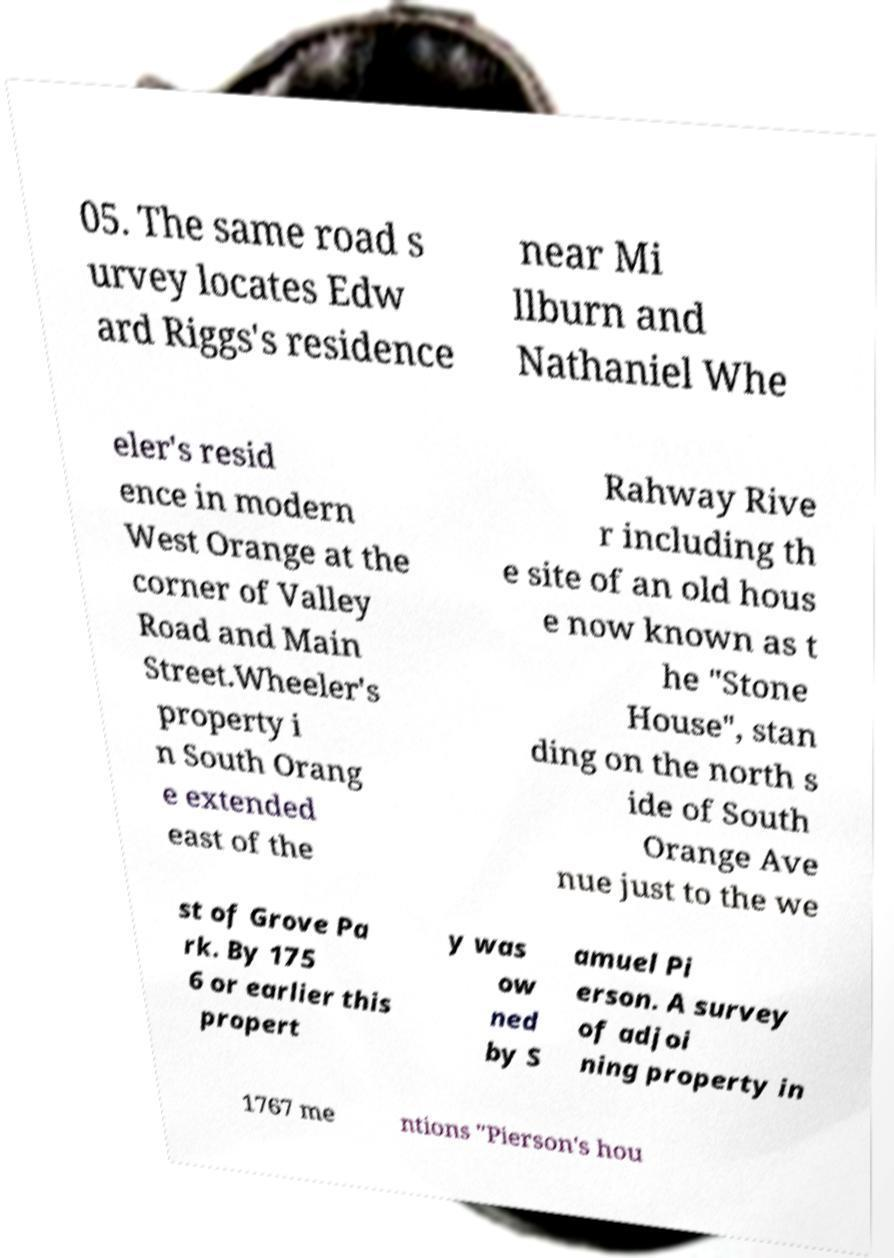Can you read and provide the text displayed in the image?This photo seems to have some interesting text. Can you extract and type it out for me? 05. The same road s urvey locates Edw ard Riggs's residence near Mi llburn and Nathaniel Whe eler's resid ence in modern West Orange at the corner of Valley Road and Main Street.Wheeler's property i n South Orang e extended east of the Rahway Rive r including th e site of an old hous e now known as t he "Stone House", stan ding on the north s ide of South Orange Ave nue just to the we st of Grove Pa rk. By 175 6 or earlier this propert y was ow ned by S amuel Pi erson. A survey of adjoi ning property in 1767 me ntions "Pierson's hou 